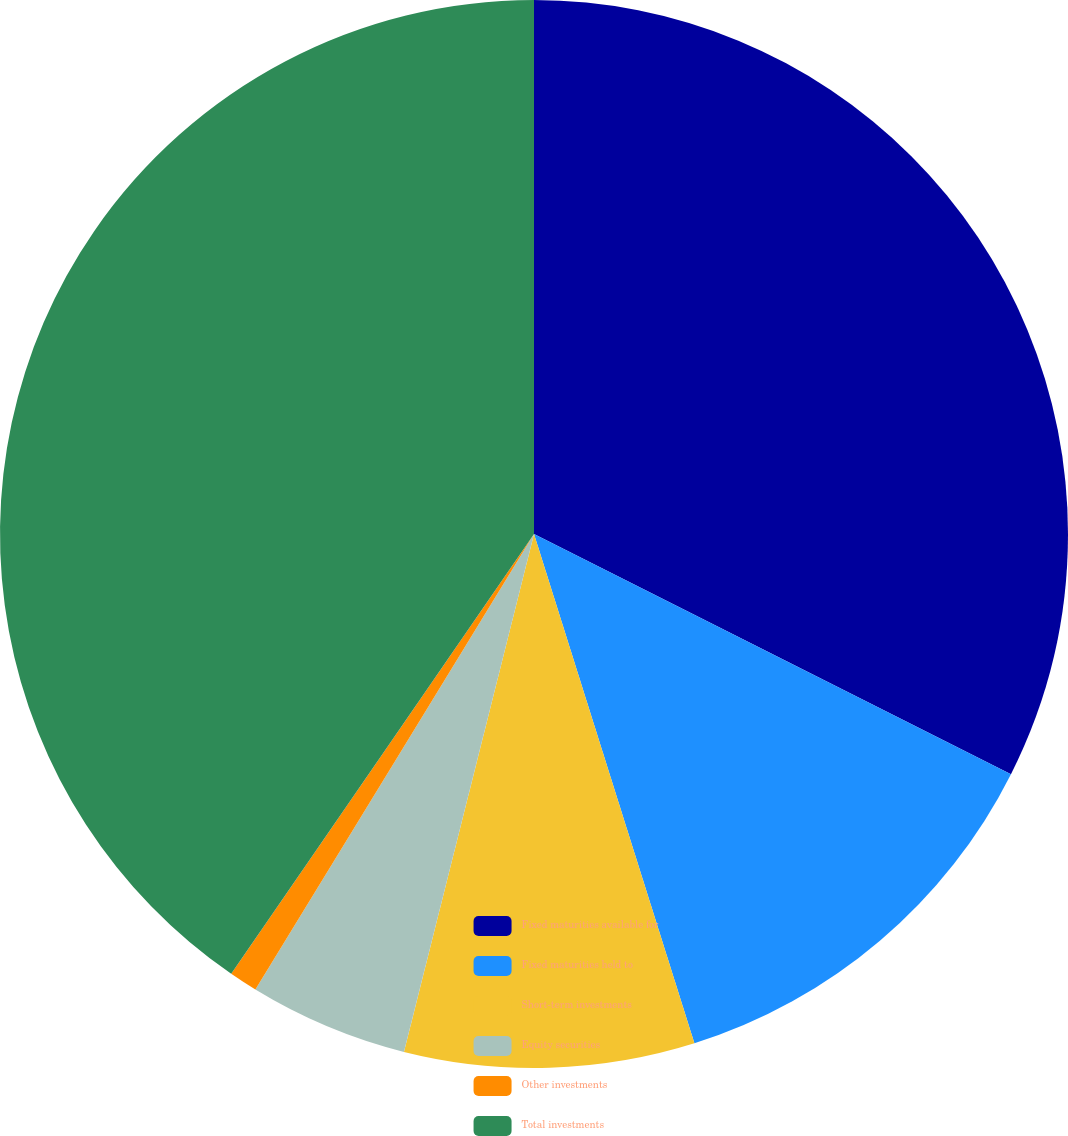<chart> <loc_0><loc_0><loc_500><loc_500><pie_chart><fcel>Fixed maturities available for<fcel>Fixed maturities held to<fcel>Short-term investments<fcel>Equity securities<fcel>Other investments<fcel>Total investments<nl><fcel>32.42%<fcel>12.72%<fcel>8.77%<fcel>4.82%<fcel>0.86%<fcel>40.4%<nl></chart> 